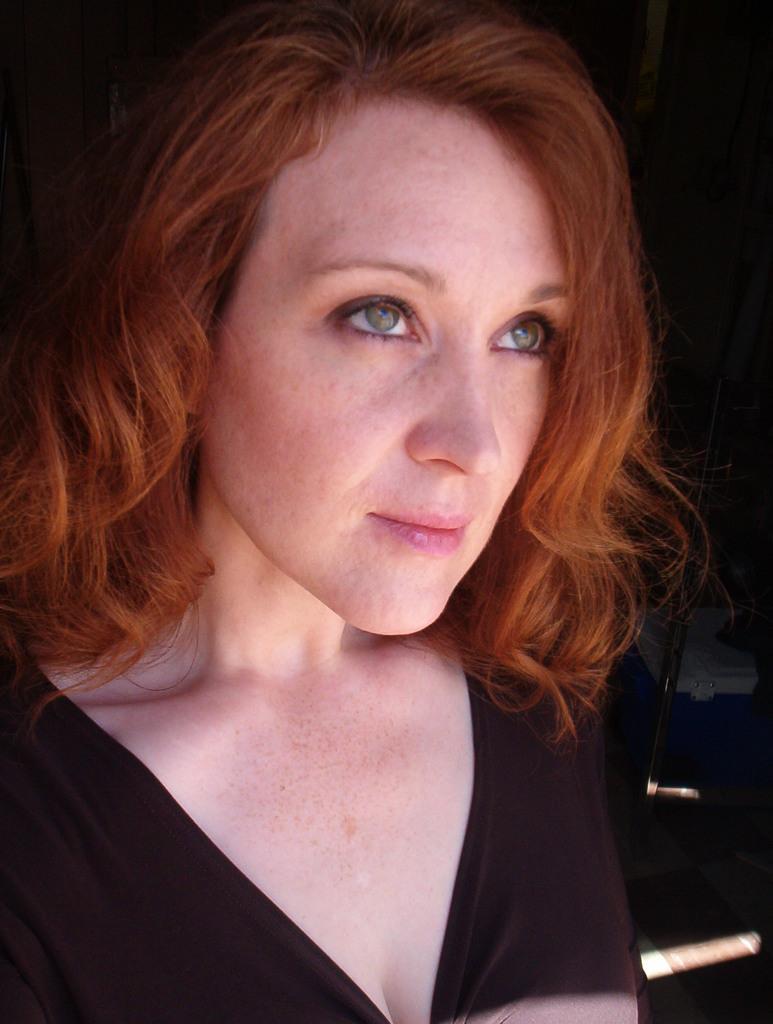Could you give a brief overview of what you see in this image? In front of the image there is a person. On the right side of the image there is a metal rod and a box on the floor. 